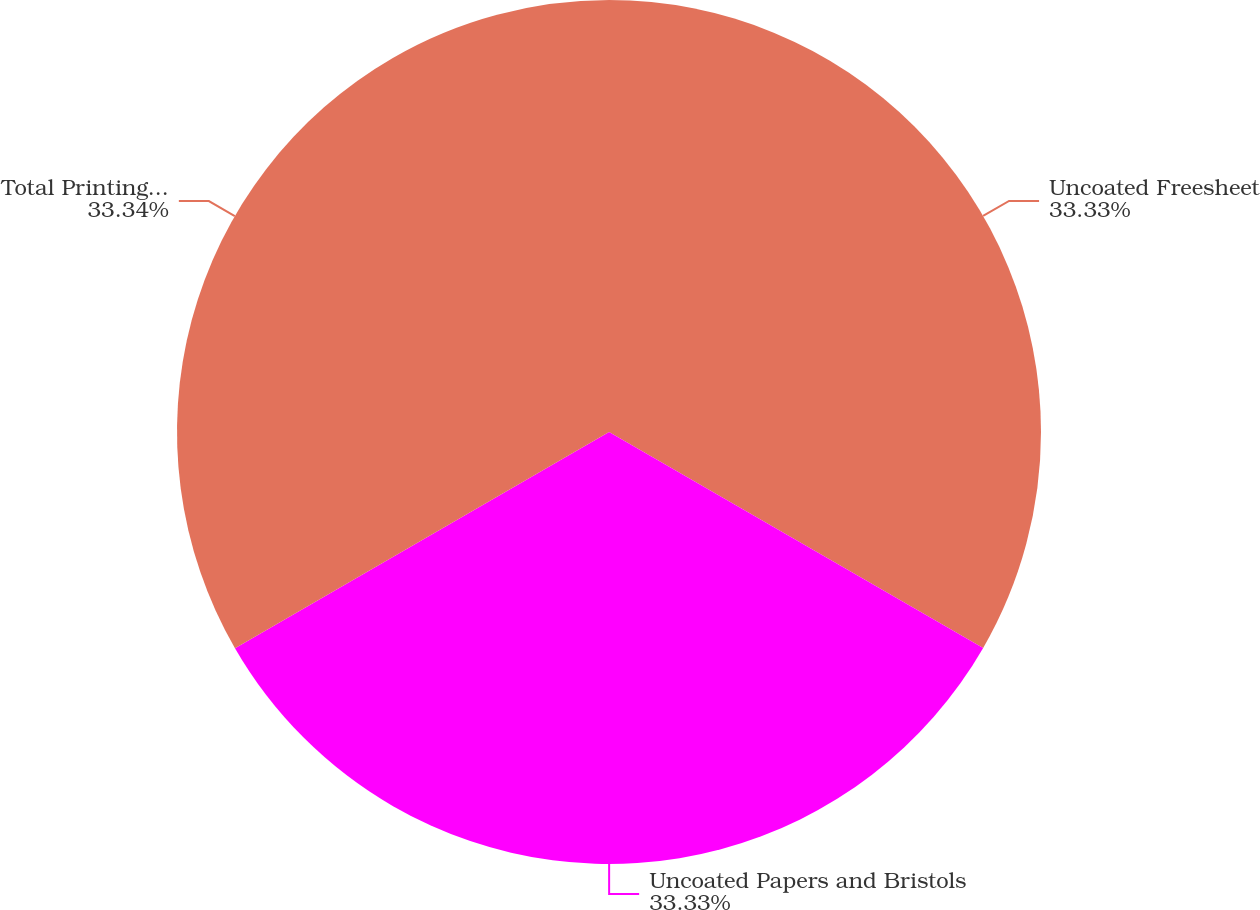Convert chart. <chart><loc_0><loc_0><loc_500><loc_500><pie_chart><fcel>Uncoated Freesheet<fcel>Uncoated Papers and Bristols<fcel>Total Printing Papers<nl><fcel>33.33%<fcel>33.33%<fcel>33.34%<nl></chart> 